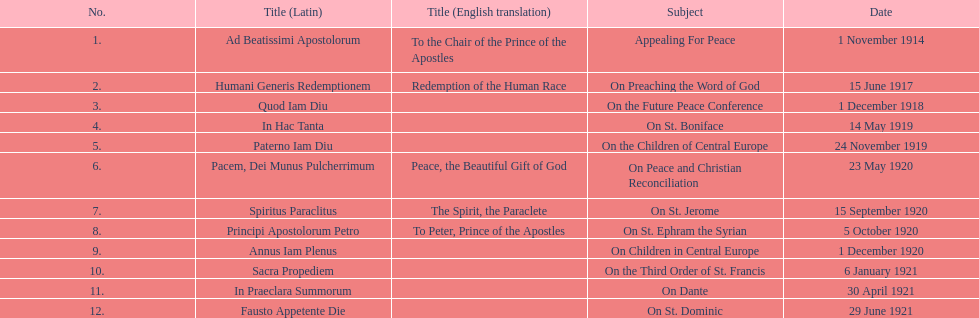How many titles were not provided with an english translation? 7. 